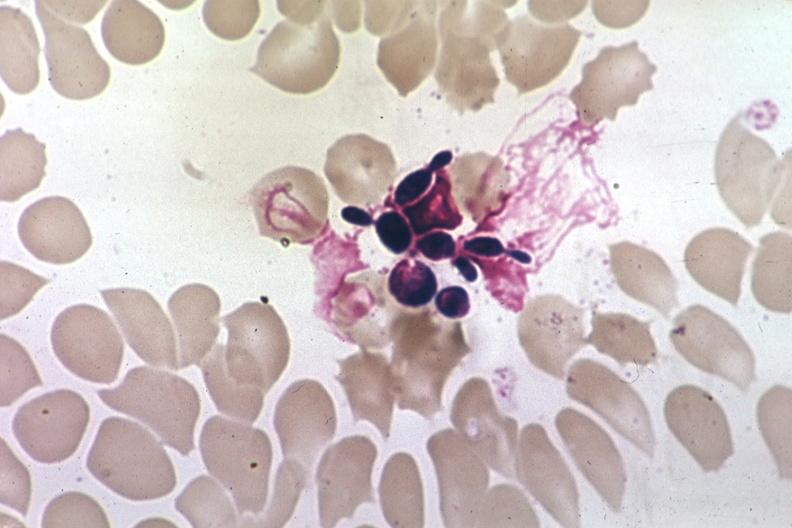does this image show wrights budding yeast forms?
Answer the question using a single word or phrase. Yes 